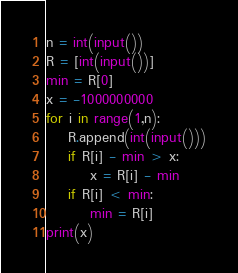Convert code to text. <code><loc_0><loc_0><loc_500><loc_500><_Python_>n = int(input())
R = [int(input())]
min = R[0]
x = -1000000000
for i in range(1,n):
    R.append(int(input()))
    if R[i] - min > x:
        x = R[i] - min
    if R[i] < min:
        min = R[i]
print(x)
</code> 